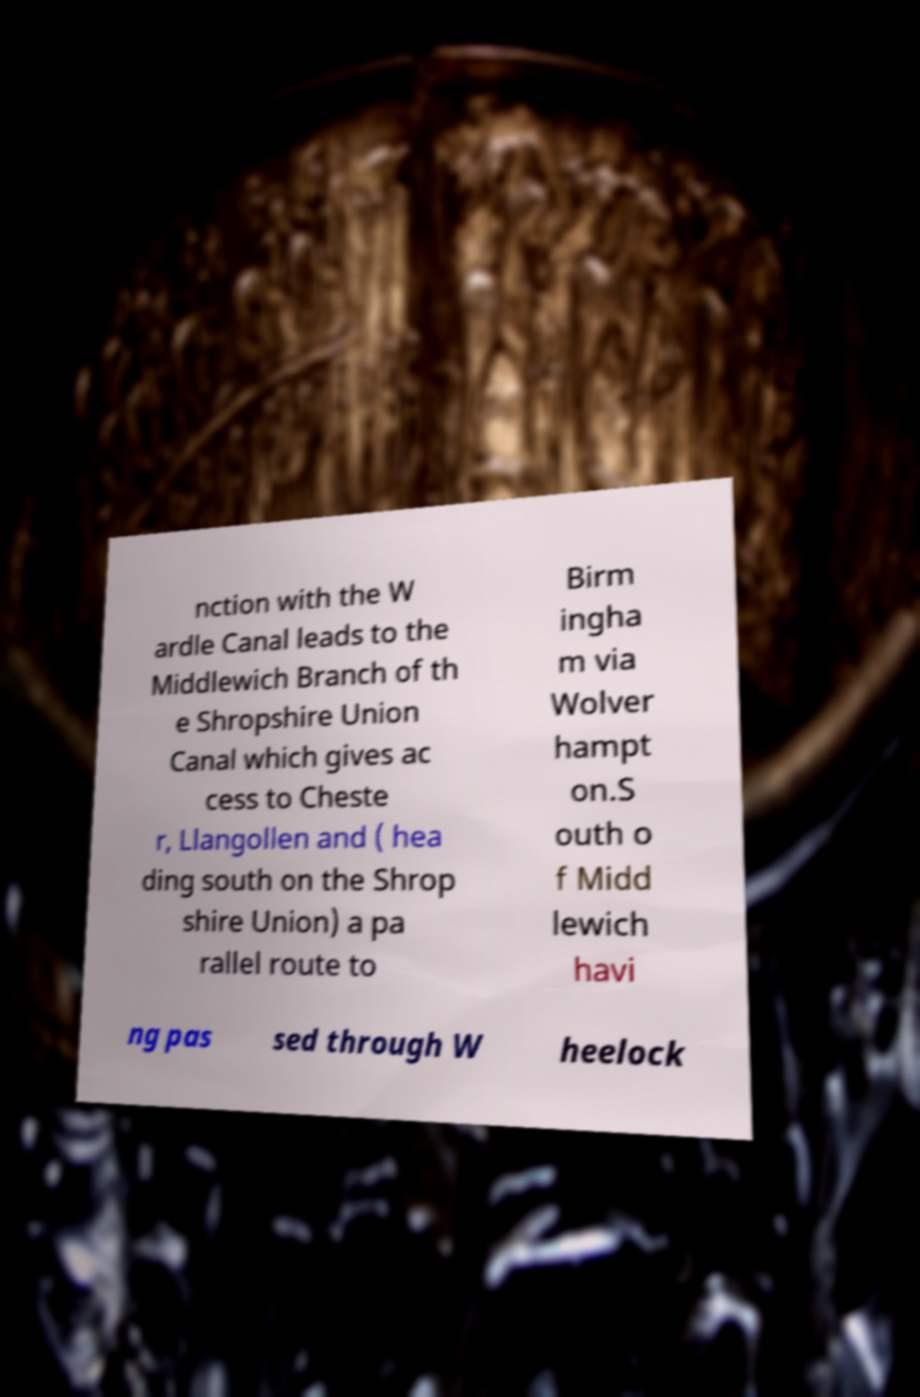Could you extract and type out the text from this image? nction with the W ardle Canal leads to the Middlewich Branch of th e Shropshire Union Canal which gives ac cess to Cheste r, Llangollen and ( hea ding south on the Shrop shire Union) a pa rallel route to Birm ingha m via Wolver hampt on.S outh o f Midd lewich havi ng pas sed through W heelock 